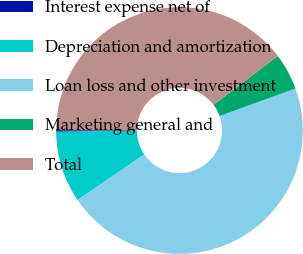<chart> <loc_0><loc_0><loc_500><loc_500><pie_chart><fcel>Interest expense net of<fcel>Depreciation and amortization<fcel>Loan loss and other investment<fcel>Marketing general and<fcel>Total<nl><fcel>0.21%<fcel>9.37%<fcel>46.0%<fcel>4.79%<fcel>39.63%<nl></chart> 